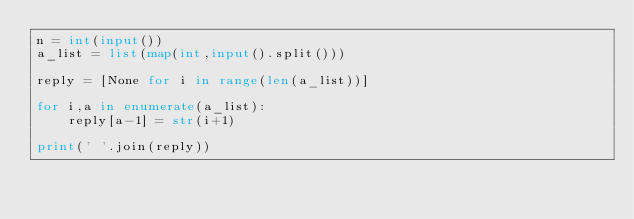Convert code to text. <code><loc_0><loc_0><loc_500><loc_500><_Python_>n = int(input())
a_list = list(map(int,input().split()))

reply = [None for i in range(len(a_list))]

for i,a in enumerate(a_list):
    reply[a-1] = str(i+1)

print(' '.join(reply))</code> 